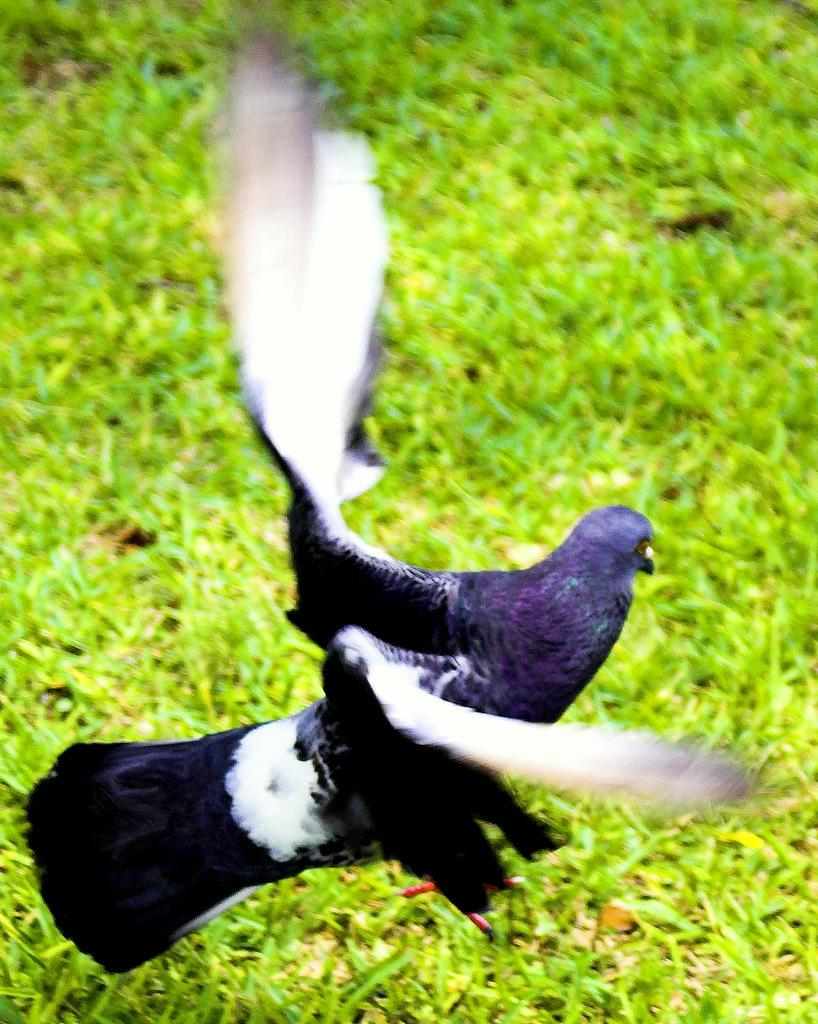What type of animal is in the image? There is a bird in the image. What is the bird standing on? The bird is standing on a grass surface. What is the bird doing with its wings? The bird has its wings open. What colors can be seen on the bird? The bird is blue in color, with white wings and a black tail. What type of tool is the bird using to build a house in the image? There is no tool or house-building activity depicted in the image; it features a bird standing on a grass surface with its wings open. What letters can be seen on the bird's wings in the image? There are no letters present on the bird's wings in the image. 